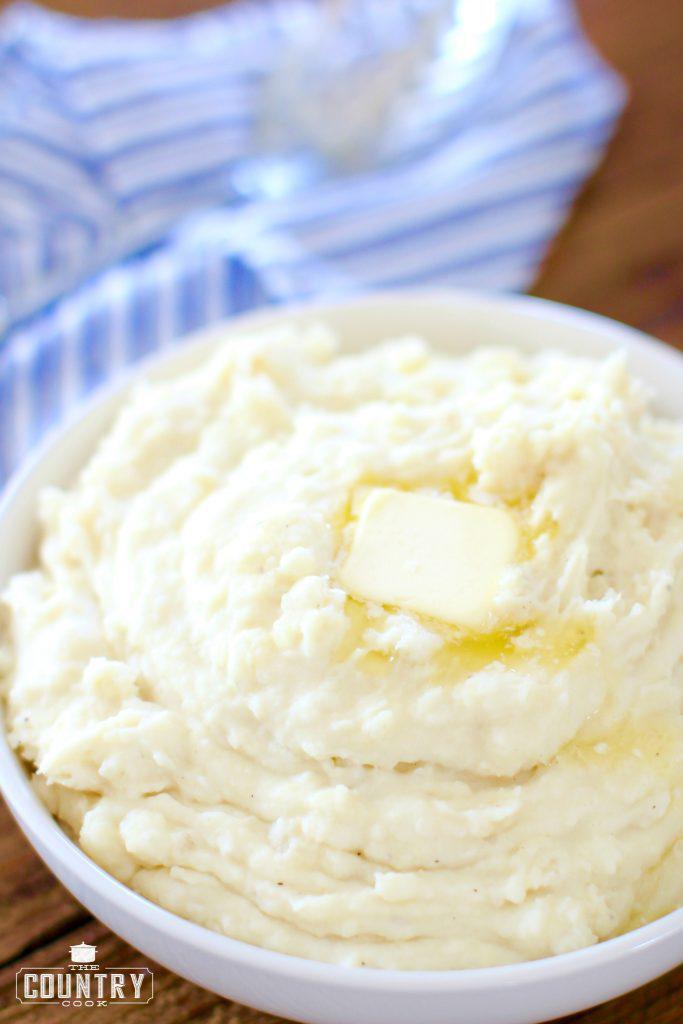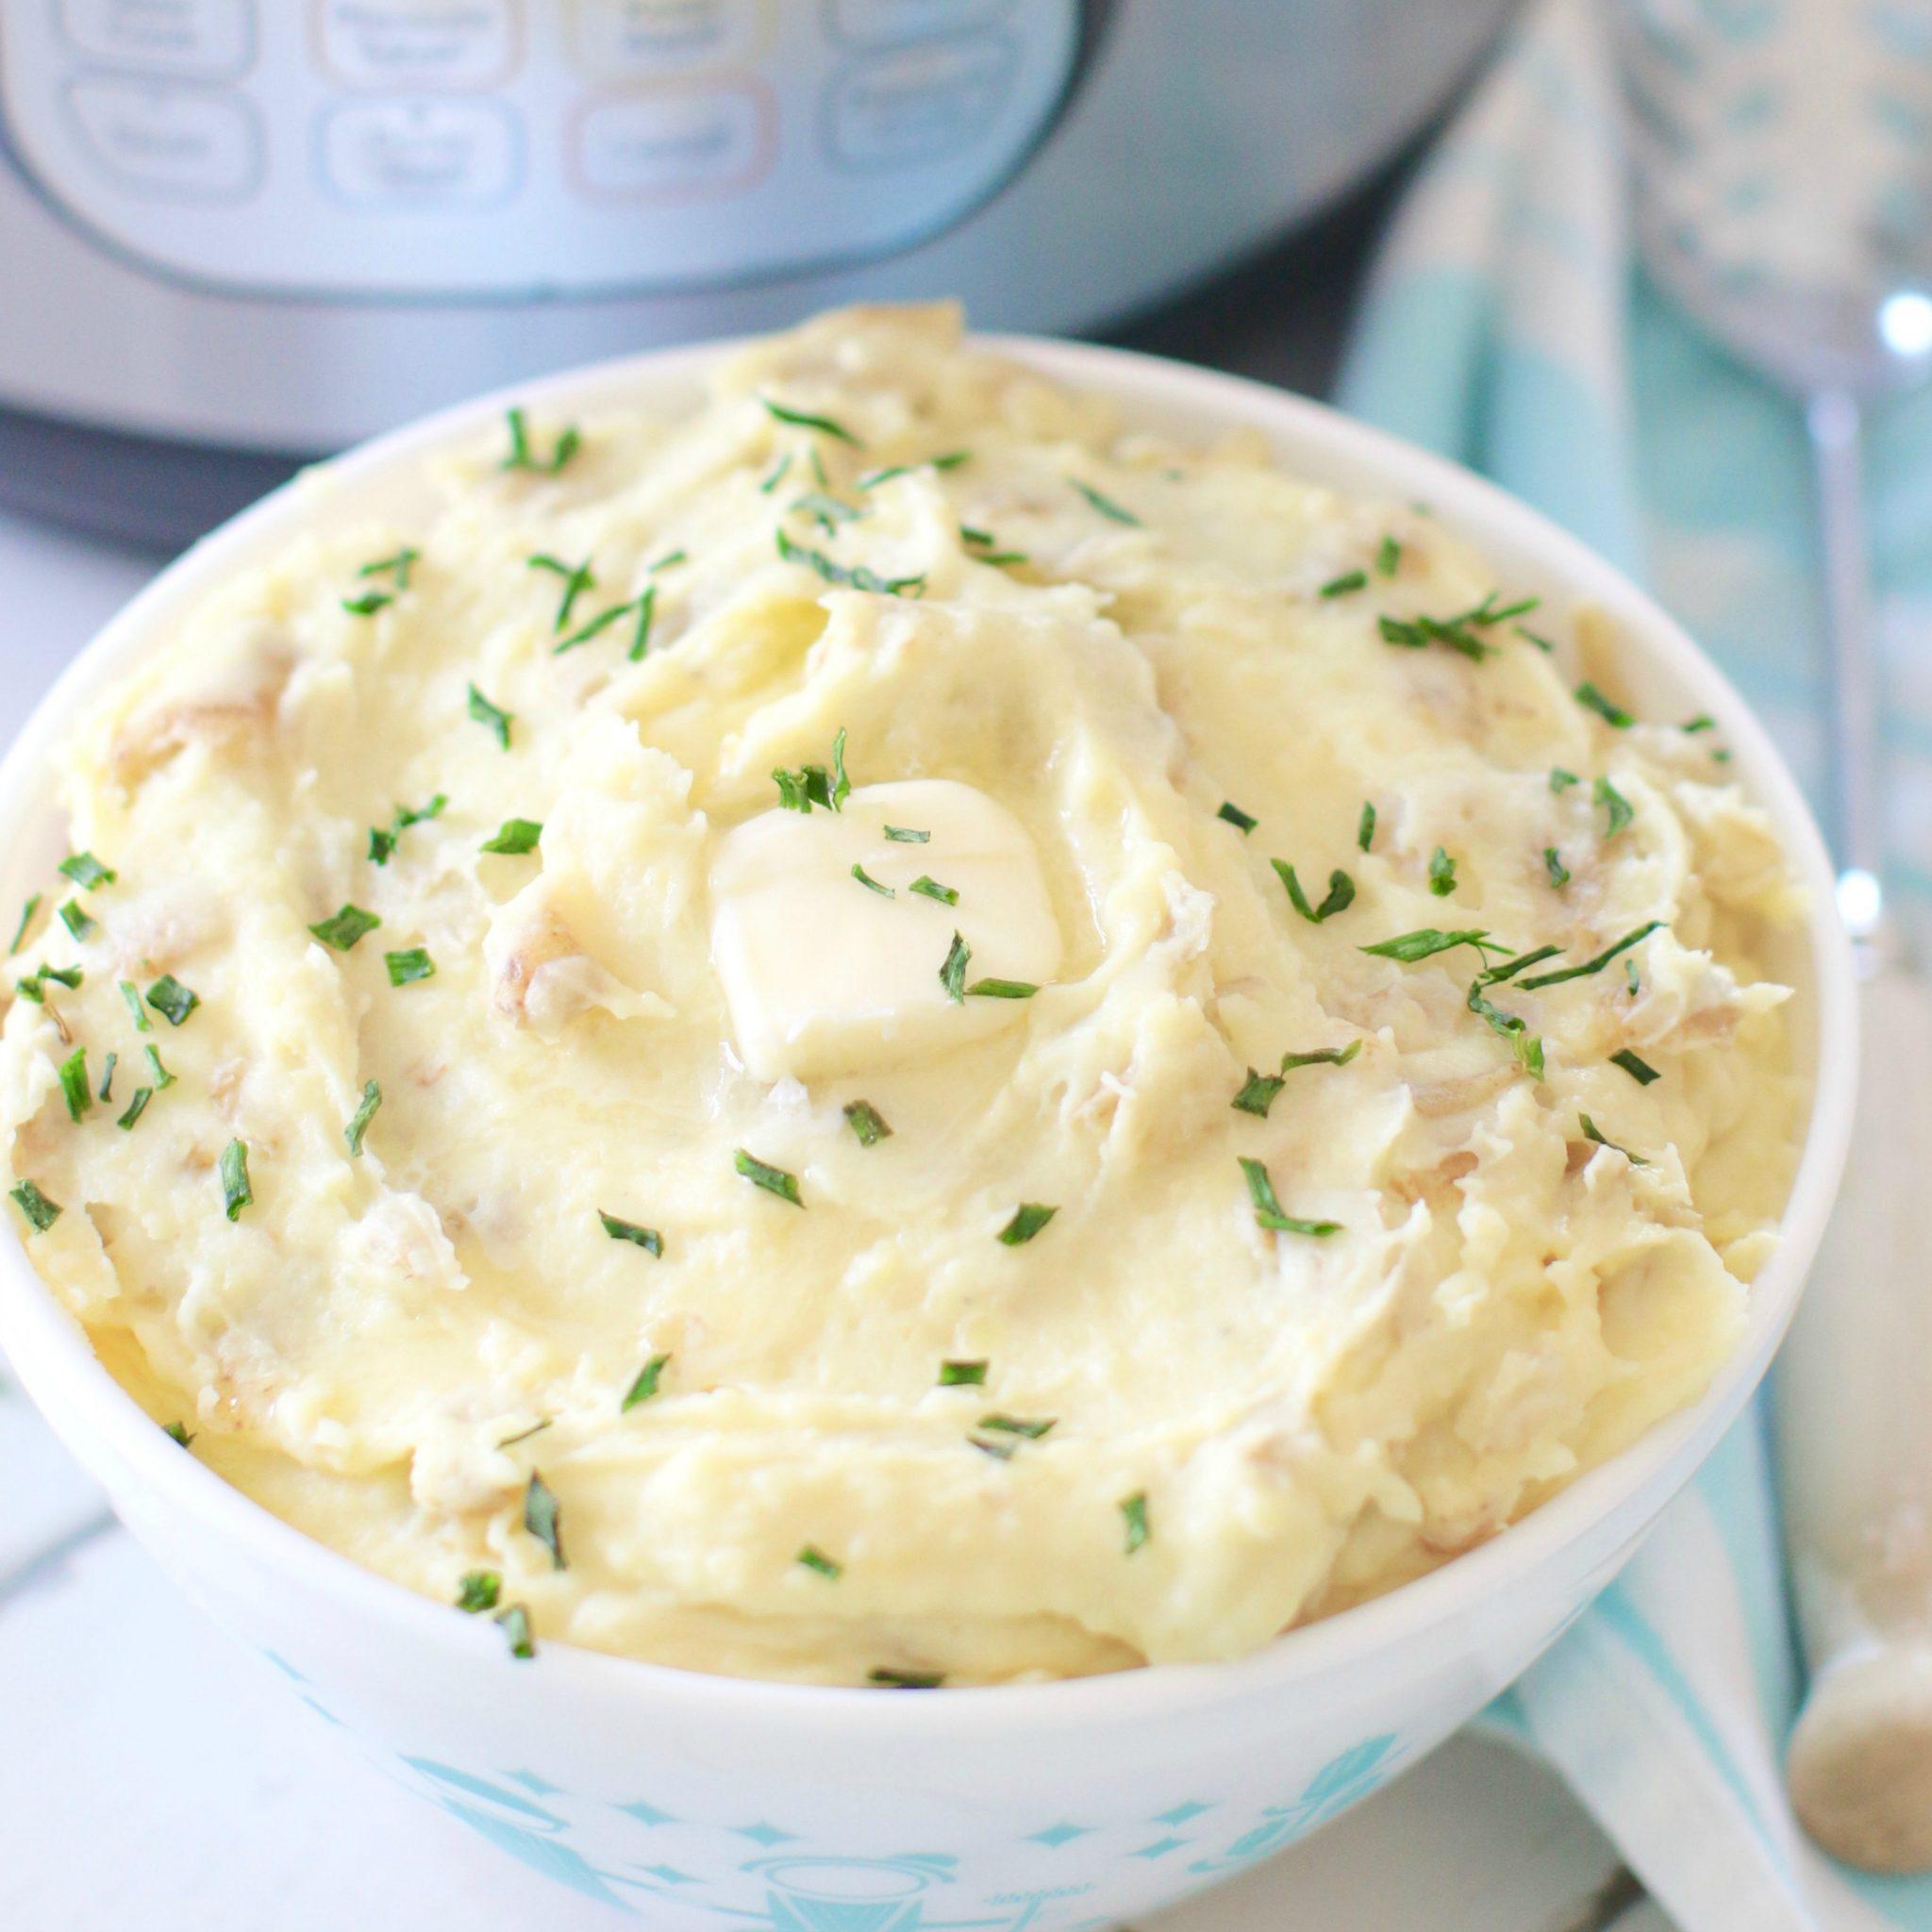The first image is the image on the left, the second image is the image on the right. Evaluate the accuracy of this statement regarding the images: "The left and right image contains the same number of mash potatoes in a single white bowl.". Is it true? Answer yes or no. Yes. The first image is the image on the left, the second image is the image on the right. Analyze the images presented: Is the assertion "An image includes ungarnished mashed potatoes in a round white bowl with a fork near it and a container of something behind it." valid? Answer yes or no. No. 